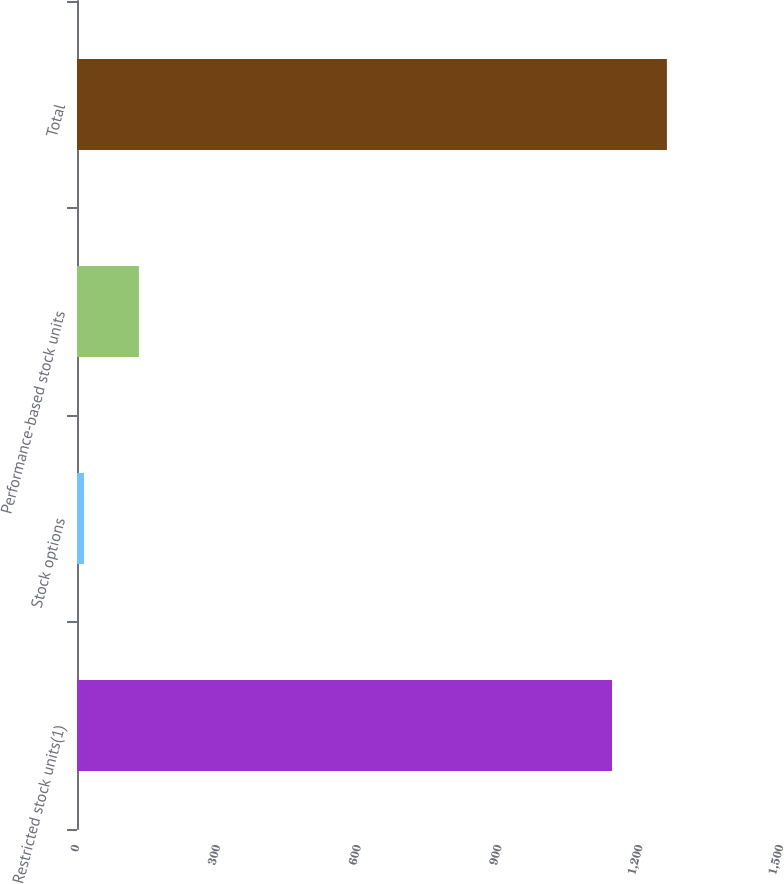<chart> <loc_0><loc_0><loc_500><loc_500><bar_chart><fcel>Restricted stock units(1)<fcel>Stock options<fcel>Performance-based stock units<fcel>Total<nl><fcel>1140<fcel>15<fcel>131.9<fcel>1256.9<nl></chart> 